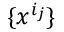<formula> <loc_0><loc_0><loc_500><loc_500>\{ x ^ { i _ { j } } \}</formula> 